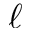<formula> <loc_0><loc_0><loc_500><loc_500>\ell</formula> 